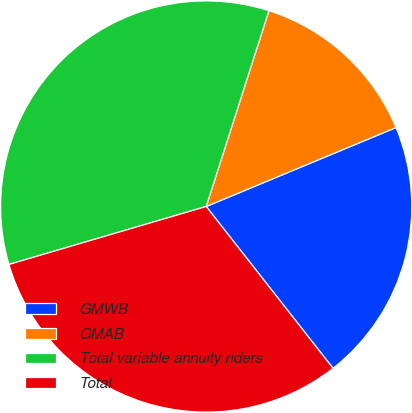Convert chart. <chart><loc_0><loc_0><loc_500><loc_500><pie_chart><fcel>GMWB<fcel>GMAB<fcel>Total variable annuity riders<fcel>Total<nl><fcel>20.69%<fcel>13.79%<fcel>34.48%<fcel>31.03%<nl></chart> 